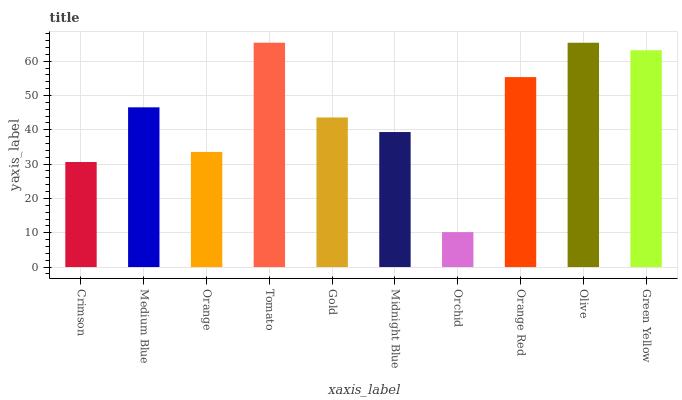Is Orchid the minimum?
Answer yes or no. Yes. Is Tomato the maximum?
Answer yes or no. Yes. Is Medium Blue the minimum?
Answer yes or no. No. Is Medium Blue the maximum?
Answer yes or no. No. Is Medium Blue greater than Crimson?
Answer yes or no. Yes. Is Crimson less than Medium Blue?
Answer yes or no. Yes. Is Crimson greater than Medium Blue?
Answer yes or no. No. Is Medium Blue less than Crimson?
Answer yes or no. No. Is Medium Blue the high median?
Answer yes or no. Yes. Is Gold the low median?
Answer yes or no. Yes. Is Tomato the high median?
Answer yes or no. No. Is Midnight Blue the low median?
Answer yes or no. No. 